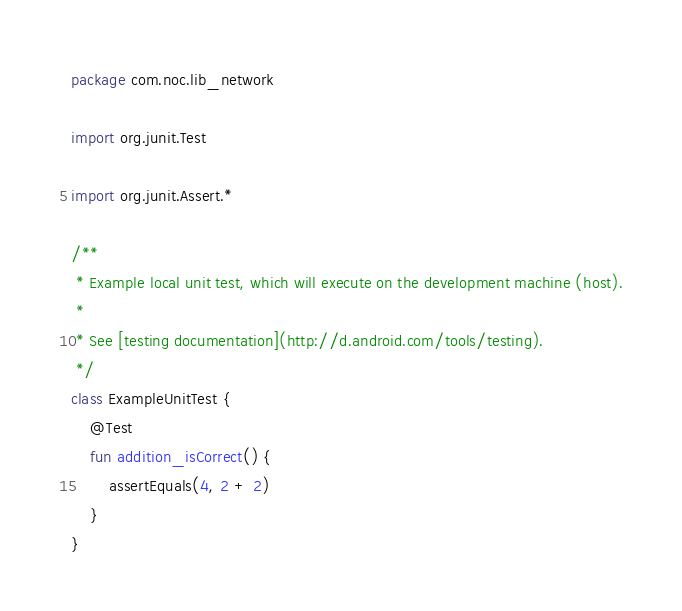Convert code to text. <code><loc_0><loc_0><loc_500><loc_500><_Kotlin_>package com.noc.lib_network

import org.junit.Test

import org.junit.Assert.*

/**
 * Example local unit test, which will execute on the development machine (host).
 *
 * See [testing documentation](http://d.android.com/tools/testing).
 */
class ExampleUnitTest {
    @Test
    fun addition_isCorrect() {
        assertEquals(4, 2 + 2)
    }
}
</code> 